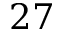<formula> <loc_0><loc_0><loc_500><loc_500>2 7</formula> 